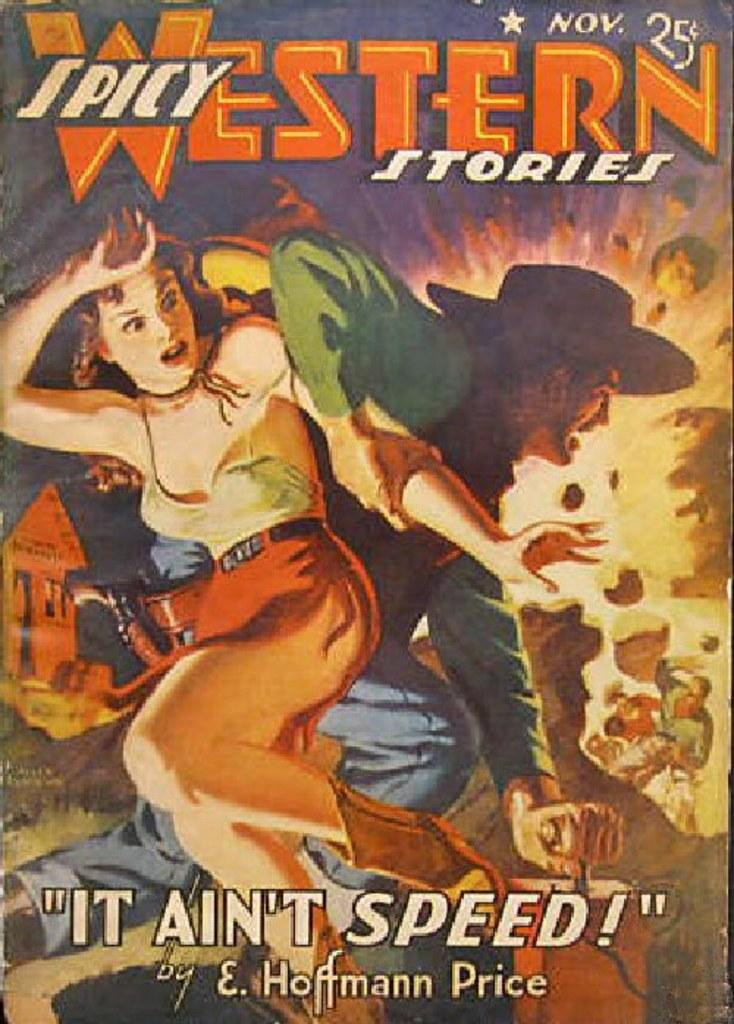What is the main subject of the image? The main subject of the image is a depiction of persons. Are there any other elements in the image besides the persons? Yes, there is text present in the image. What type of fruit is being enjoyed by the persons in the image? There is no fruit present in the image; it only depicts persons and text. Can you describe the window through which the persons are looking in the image? There is no window present in the image; it only depicts persons and text. 